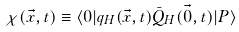Convert formula to latex. <formula><loc_0><loc_0><loc_500><loc_500>\chi ( \vec { x } , t ) \equiv \langle 0 | q _ { H } ( \vec { x } , t ) \bar { Q } _ { H } ( \vec { 0 } , t ) | P \rangle</formula> 